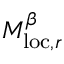<formula> <loc_0><loc_0><loc_500><loc_500>M _ { l o c , r } ^ { \beta }</formula> 